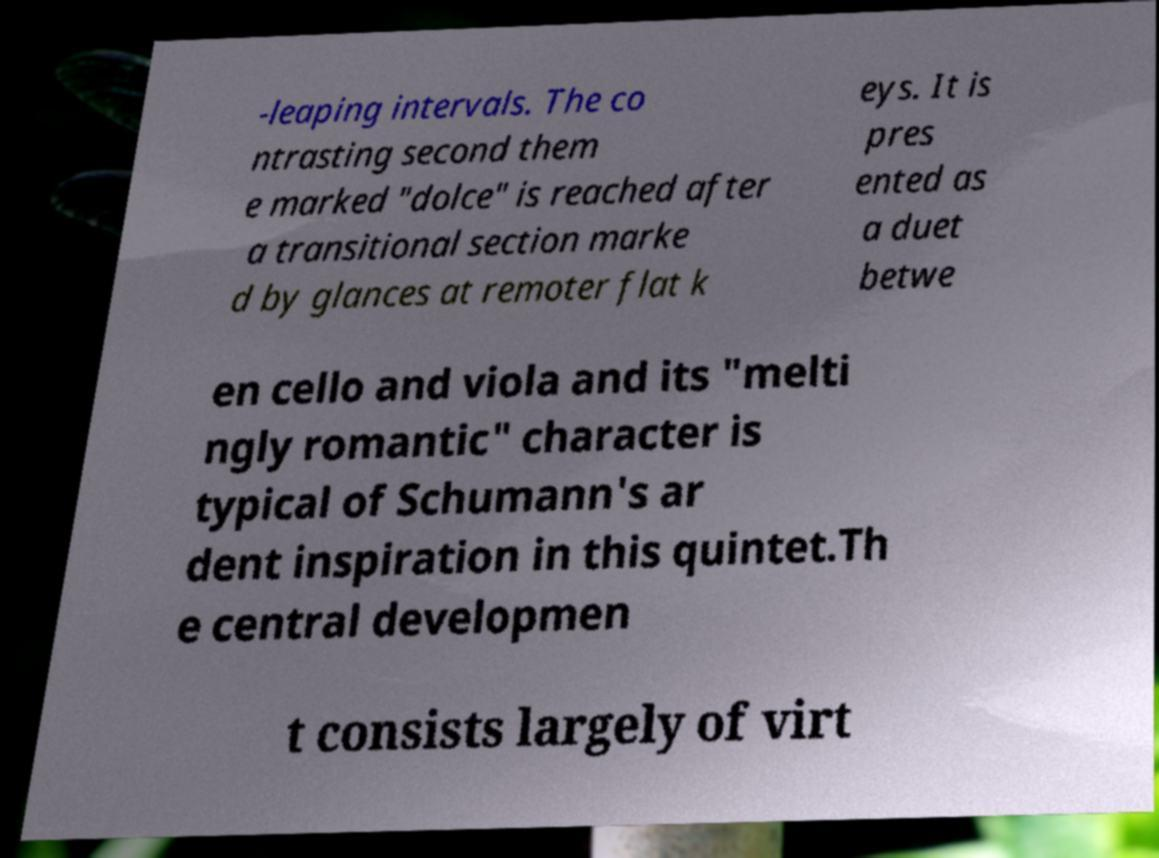What messages or text are displayed in this image? I need them in a readable, typed format. -leaping intervals. The co ntrasting second them e marked "dolce" is reached after a transitional section marke d by glances at remoter flat k eys. It is pres ented as a duet betwe en cello and viola and its "melti ngly romantic" character is typical of Schumann's ar dent inspiration in this quintet.Th e central developmen t consists largely of virt 